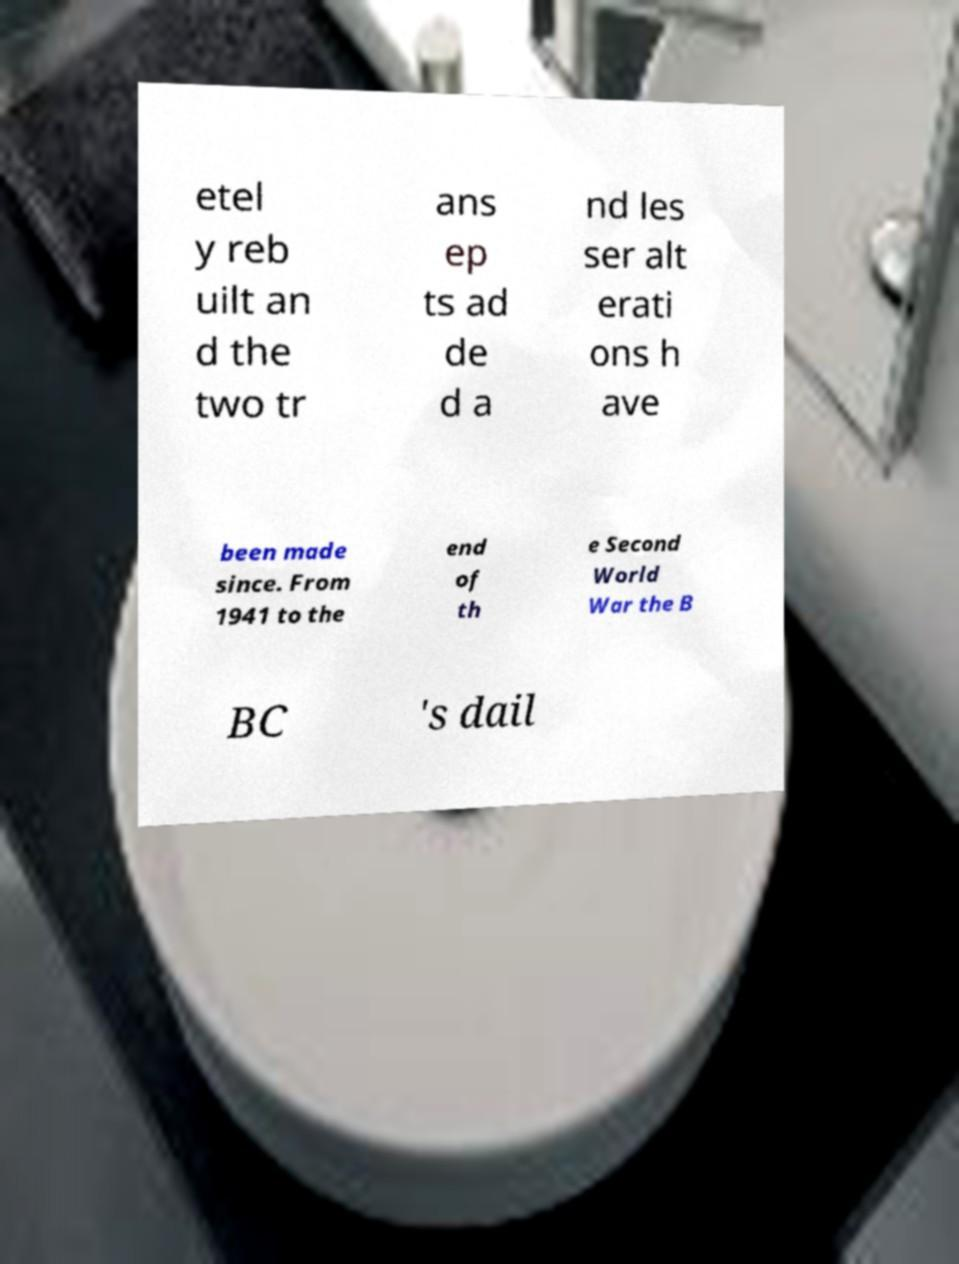Please read and relay the text visible in this image. What does it say? etel y reb uilt an d the two tr ans ep ts ad de d a nd les ser alt erati ons h ave been made since. From 1941 to the end of th e Second World War the B BC 's dail 